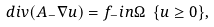Convert formula to latex. <formula><loc_0><loc_0><loc_500><loc_500>d i v ( A _ { - } \nabla u ) = f _ { - } i n \Omega \ \{ u \geq 0 \} ,</formula> 